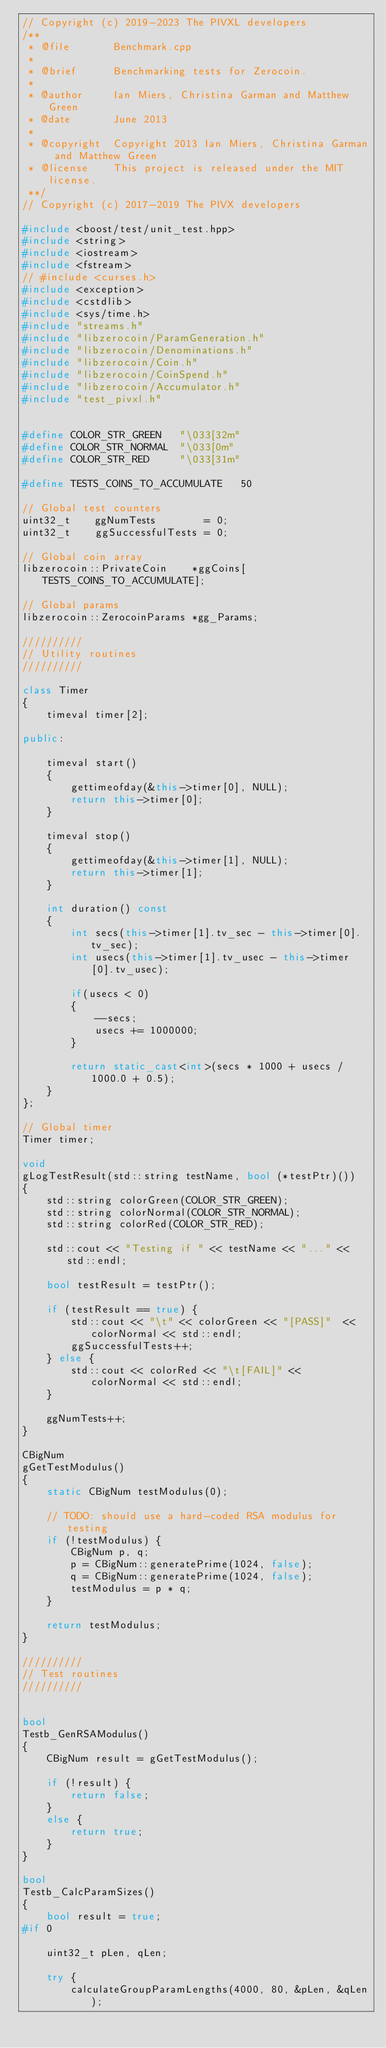Convert code to text. <code><loc_0><loc_0><loc_500><loc_500><_C++_>// Copyright (c) 2019-2023 The PIVXL developers
/**
 * @file       Benchmark.cpp
 *
 * @brief      Benchmarking tests for Zerocoin.
 *
 * @author     Ian Miers, Christina Garman and Matthew Green
 * @date       June 2013
 *
 * @copyright  Copyright 2013 Ian Miers, Christina Garman and Matthew Green
 * @license    This project is released under the MIT license.
 **/
// Copyright (c) 2017-2019 The PIVX developers

#include <boost/test/unit_test.hpp>
#include <string>
#include <iostream>
#include <fstream>
// #include <curses.h>
#include <exception>
#include <cstdlib>
#include <sys/time.h>
#include "streams.h"
#include "libzerocoin/ParamGeneration.h"
#include "libzerocoin/Denominations.h"
#include "libzerocoin/Coin.h"
#include "libzerocoin/CoinSpend.h"
#include "libzerocoin/Accumulator.h"
#include "test_pivxl.h"


#define COLOR_STR_GREEN   "\033[32m"
#define COLOR_STR_NORMAL  "\033[0m"
#define COLOR_STR_RED     "\033[31m"

#define TESTS_COINS_TO_ACCUMULATE   50

// Global test counters
uint32_t    ggNumTests        = 0;
uint32_t    ggSuccessfulTests = 0;

// Global coin array
libzerocoin::PrivateCoin    *ggCoins[TESTS_COINS_TO_ACCUMULATE];

// Global params
libzerocoin::ZerocoinParams *gg_Params;

//////////
// Utility routines
//////////

class Timer
{
    timeval timer[2];

public:

    timeval start()
    {
        gettimeofday(&this->timer[0], NULL);
        return this->timer[0];
    }

    timeval stop()
    {
        gettimeofday(&this->timer[1], NULL);
        return this->timer[1];
    }

    int duration() const
    {
        int secs(this->timer[1].tv_sec - this->timer[0].tv_sec);
        int usecs(this->timer[1].tv_usec - this->timer[0].tv_usec);

        if(usecs < 0)
        {
            --secs;
            usecs += 1000000;
        }

        return static_cast<int>(secs * 1000 + usecs / 1000.0 + 0.5);
    }
};

// Global timer
Timer timer;

void
gLogTestResult(std::string testName, bool (*testPtr)())
{
    std::string colorGreen(COLOR_STR_GREEN);
    std::string colorNormal(COLOR_STR_NORMAL);
    std::string colorRed(COLOR_STR_RED);

    std::cout << "Testing if " << testName << "..." << std::endl;

    bool testResult = testPtr();

    if (testResult == true) {
        std::cout << "\t" << colorGreen << "[PASS]"  << colorNormal << std::endl;
        ggSuccessfulTests++;
    } else {
        std::cout << colorRed << "\t[FAIL]" << colorNormal << std::endl;
    }

    ggNumTests++;
}

CBigNum
gGetTestModulus()
{
    static CBigNum testModulus(0);

    // TODO: should use a hard-coded RSA modulus for testing
    if (!testModulus) {
        CBigNum p, q;
        p = CBigNum::generatePrime(1024, false);
        q = CBigNum::generatePrime(1024, false);
        testModulus = p * q;
    }

    return testModulus;
}

//////////
// Test routines
//////////


bool
Testb_GenRSAModulus()
{
    CBigNum result = gGetTestModulus();

    if (!result) {
        return false;
    }
    else {
        return true;
    }
}

bool
Testb_CalcParamSizes()
{
    bool result = true;
#if 0

    uint32_t pLen, qLen;

    try {
        calculateGroupParamLengths(4000, 80, &pLen, &qLen);</code> 